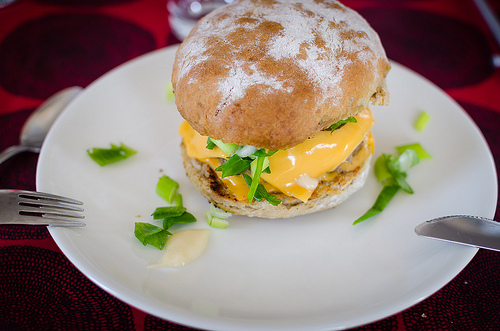<image>
Is there a burger on the plate? Yes. Looking at the image, I can see the burger is positioned on top of the plate, with the plate providing support. Is there a mayo in front of the plate? No. The mayo is not in front of the plate. The spatial positioning shows a different relationship between these objects. 